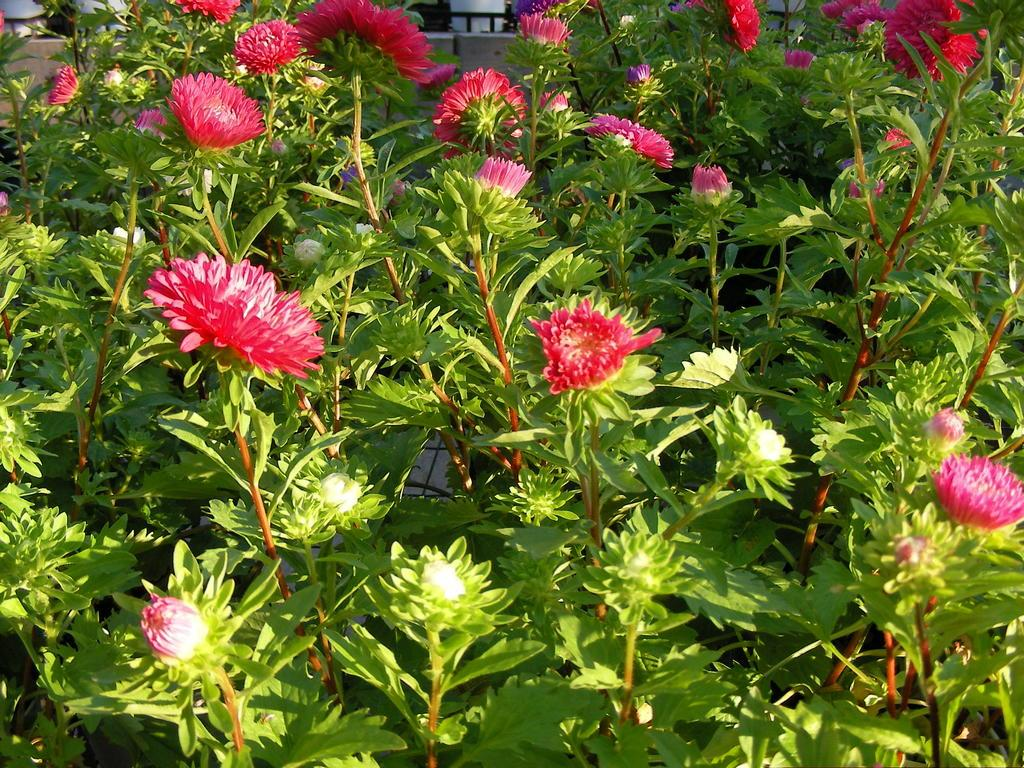What type of living organisms can be seen in the image? There are flowers in the image, which are associated with plants. What is the relationship between the flowers and the plants? The flowers are part of the plants, growing on them. What can be seen in the background of the image? There appears to be a house in the background of the image. What type of pump is visible in the image? There is no pump present in the image. What type of milk is being used to paint the canvas in the image? There is no canvas or milk present in the image. 